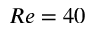Convert formula to latex. <formula><loc_0><loc_0><loc_500><loc_500>R e = 4 0</formula> 